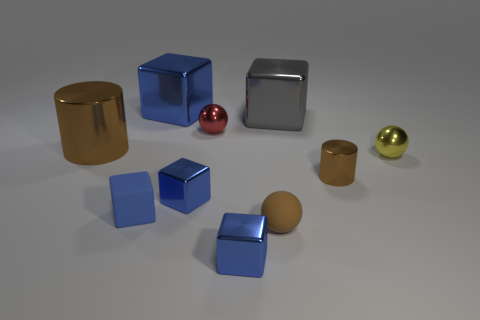How many blue blocks must be subtracted to get 1 blue blocks? 3 Subtract all gray cylinders. How many blue cubes are left? 4 Subtract all gray metallic blocks. How many blocks are left? 4 Subtract all gray blocks. How many blocks are left? 4 Subtract all yellow cubes. Subtract all green spheres. How many cubes are left? 5 Subtract all cylinders. How many objects are left? 8 Subtract all big red matte spheres. Subtract all small blue shiny objects. How many objects are left? 8 Add 5 yellow objects. How many yellow objects are left? 6 Add 2 red shiny balls. How many red shiny balls exist? 3 Subtract 2 blue blocks. How many objects are left? 8 